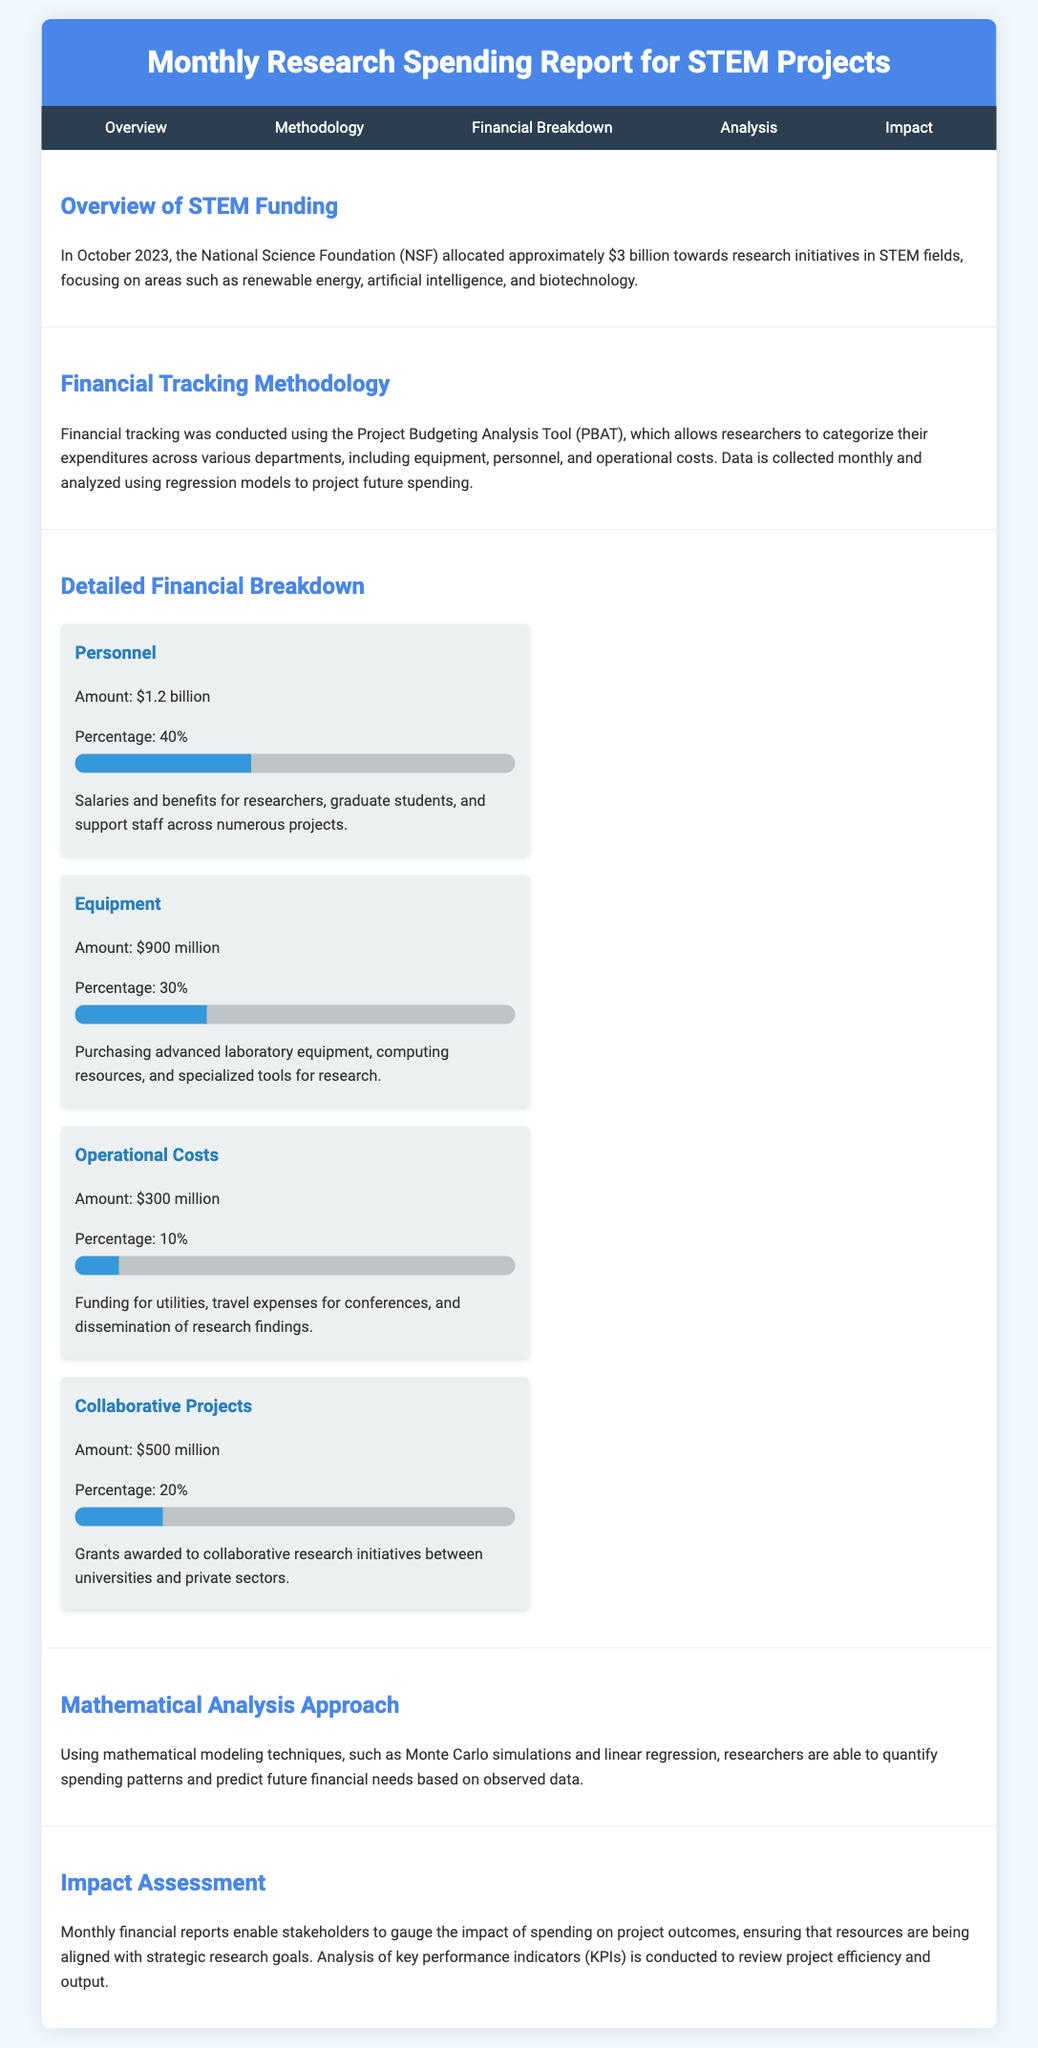What is the total funding allocated for October 2023? The total funding allocated is explicitly stated in the overview section as approximately $3 billion.
Answer: $3 billion What percentage of the budget is allocated to personnel? The percentage allocated to personnel is noted in the financial breakdown section as 40%.
Answer: 40% How much funding is allocated for equipment? The financial breakdown section specifies that the funding allocated for equipment is $900 million.
Answer: $900 million What is the purpose of the Project Budgeting Analysis Tool (PBAT)? The methodology section describes the purpose of PBAT as a tool for categorizing expenditures across various departments.
Answer: Categorizing expenditures What is the amount allocated for operational costs? The financial breakdown section reveals the amount allocated for operational costs as $300 million.
Answer: $300 million What percentage of the budget does collaborative projects represent? The financial breakdown section indicates that collaborative projects represent 20% of the budget.
Answer: 20% What mathematical techniques are mentioned for analyzing spending patterns? The analysis section states that mathematical modeling techniques mentioned include Monte Carlo simulations and linear regression.
Answer: Monte Carlo simulations and linear regression How can stakeholders gauge the impact of spending? The impact assessment section explains that monthly financial reports enable stakeholders to gauge the impact of spending on project outcomes.
Answer: Monthly financial reports What is the focus of the NSF funding for STEM fields in October 2023? The overview section highlights that the focus areas include renewable energy, artificial intelligence, and biotechnology.
Answer: Renewable energy, artificial intelligence, and biotechnology 